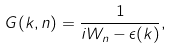Convert formula to latex. <formula><loc_0><loc_0><loc_500><loc_500>G ( { k } , n ) = \frac { 1 } { i W _ { n } - \epsilon ( { k } ) } ,</formula> 